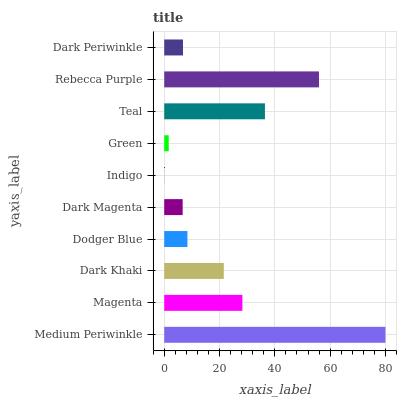Is Indigo the minimum?
Answer yes or no. Yes. Is Medium Periwinkle the maximum?
Answer yes or no. Yes. Is Magenta the minimum?
Answer yes or no. No. Is Magenta the maximum?
Answer yes or no. No. Is Medium Periwinkle greater than Magenta?
Answer yes or no. Yes. Is Magenta less than Medium Periwinkle?
Answer yes or no. Yes. Is Magenta greater than Medium Periwinkle?
Answer yes or no. No. Is Medium Periwinkle less than Magenta?
Answer yes or no. No. Is Dark Khaki the high median?
Answer yes or no. Yes. Is Dodger Blue the low median?
Answer yes or no. Yes. Is Green the high median?
Answer yes or no. No. Is Rebecca Purple the low median?
Answer yes or no. No. 